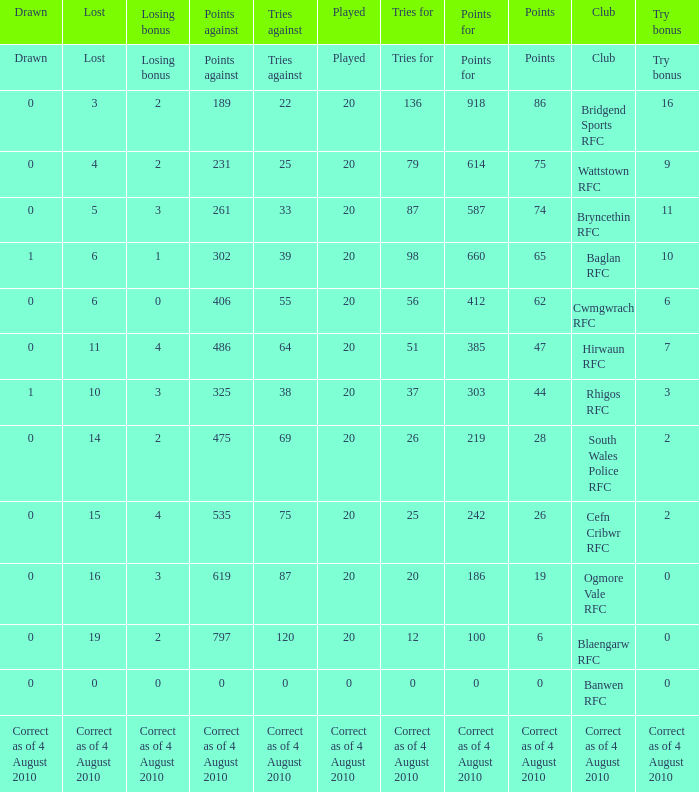What is the points against when the losing bonus is 0 and the club is banwen rfc? 0.0. 